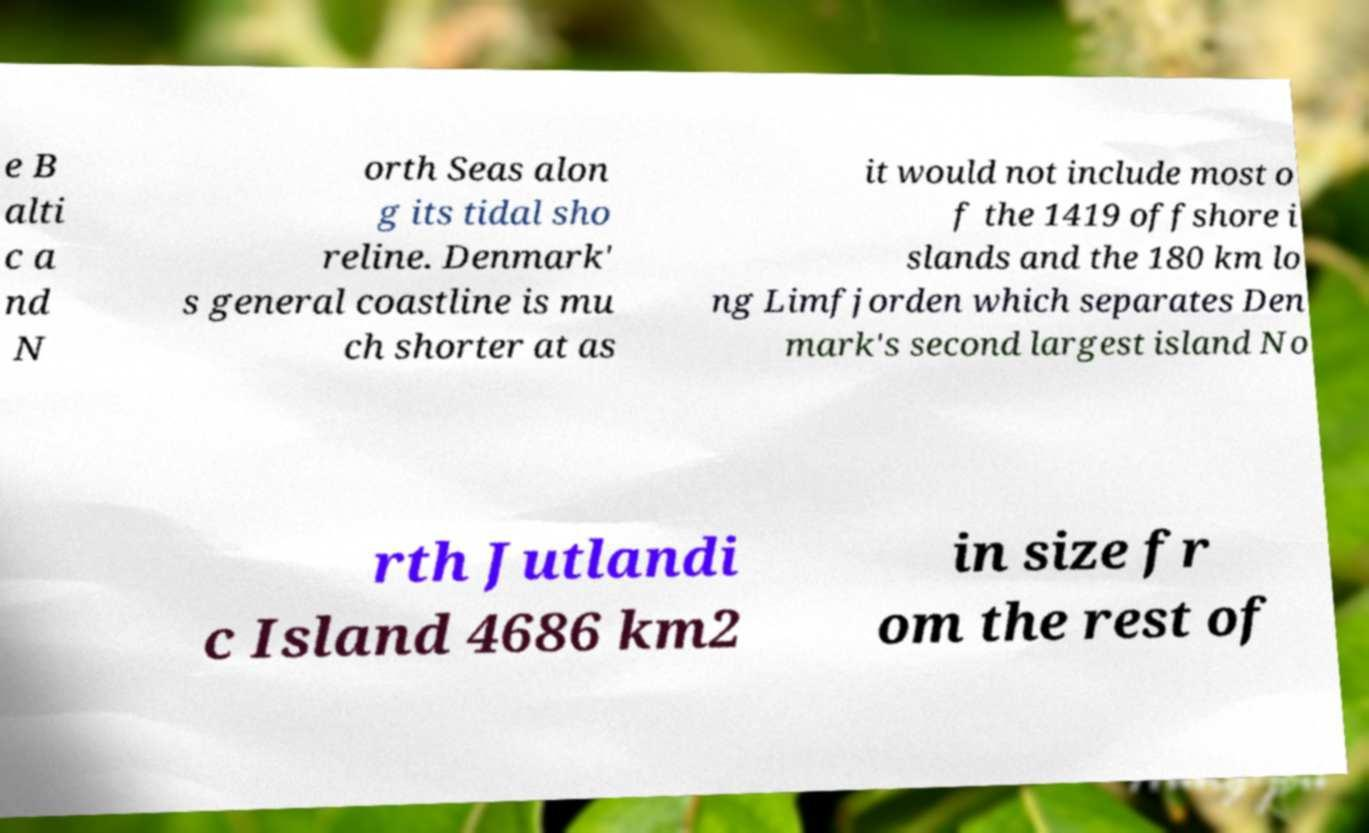For documentation purposes, I need the text within this image transcribed. Could you provide that? e B alti c a nd N orth Seas alon g its tidal sho reline. Denmark' s general coastline is mu ch shorter at as it would not include most o f the 1419 offshore i slands and the 180 km lo ng Limfjorden which separates Den mark's second largest island No rth Jutlandi c Island 4686 km2 in size fr om the rest of 